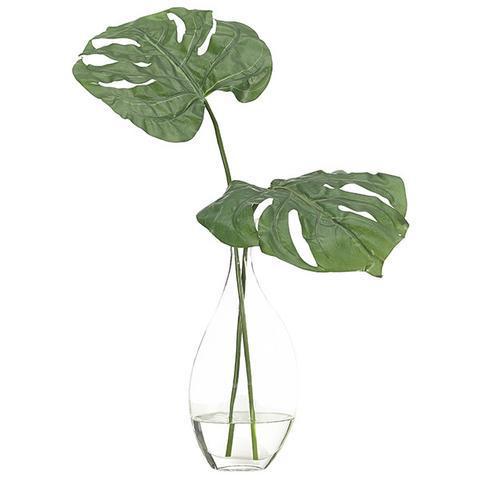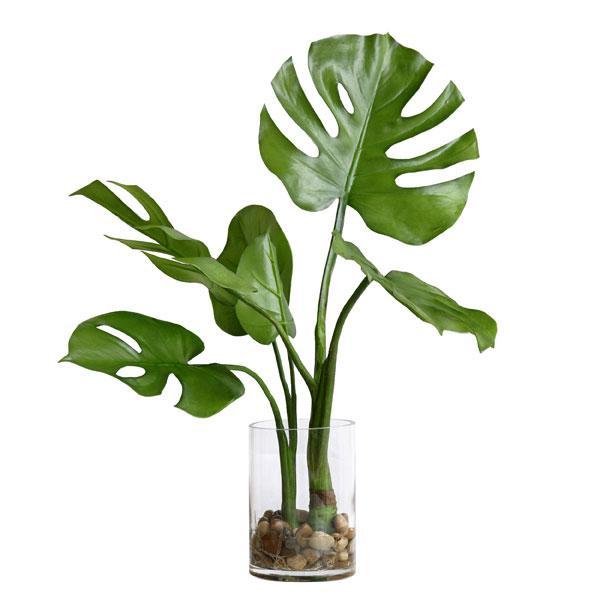The first image is the image on the left, the second image is the image on the right. Given the left and right images, does the statement "The left image shows a vase containing only water and multiple leaves, and the right image features a vase with something besides water or a leaf in it." hold true? Answer yes or no. Yes. The first image is the image on the left, the second image is the image on the right. Considering the images on both sides, is "In one of the images the plant is in a vase with only water." valid? Answer yes or no. Yes. 